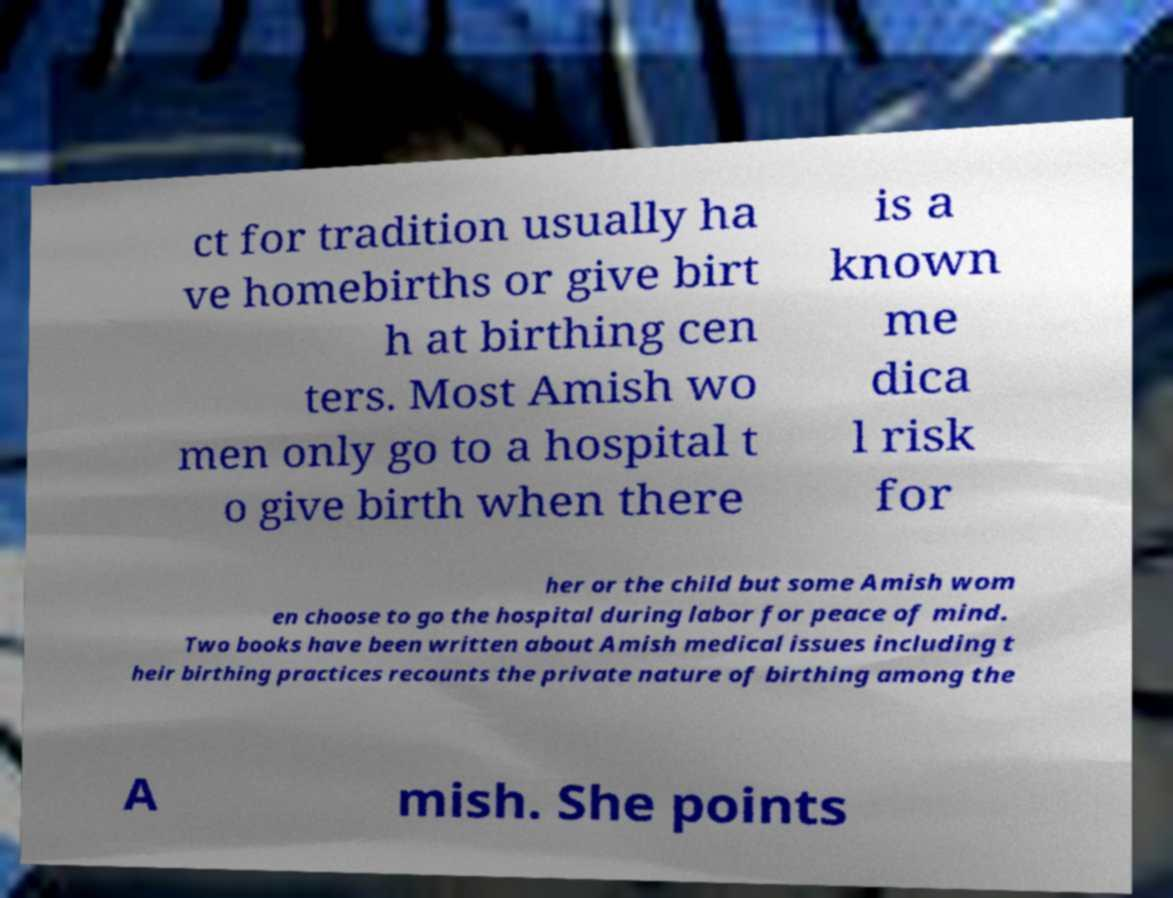What messages or text are displayed in this image? I need them in a readable, typed format. ct for tradition usually ha ve homebirths or give birt h at birthing cen ters. Most Amish wo men only go to a hospital t o give birth when there is a known me dica l risk for her or the child but some Amish wom en choose to go the hospital during labor for peace of mind. Two books have been written about Amish medical issues including t heir birthing practices recounts the private nature of birthing among the A mish. She points 